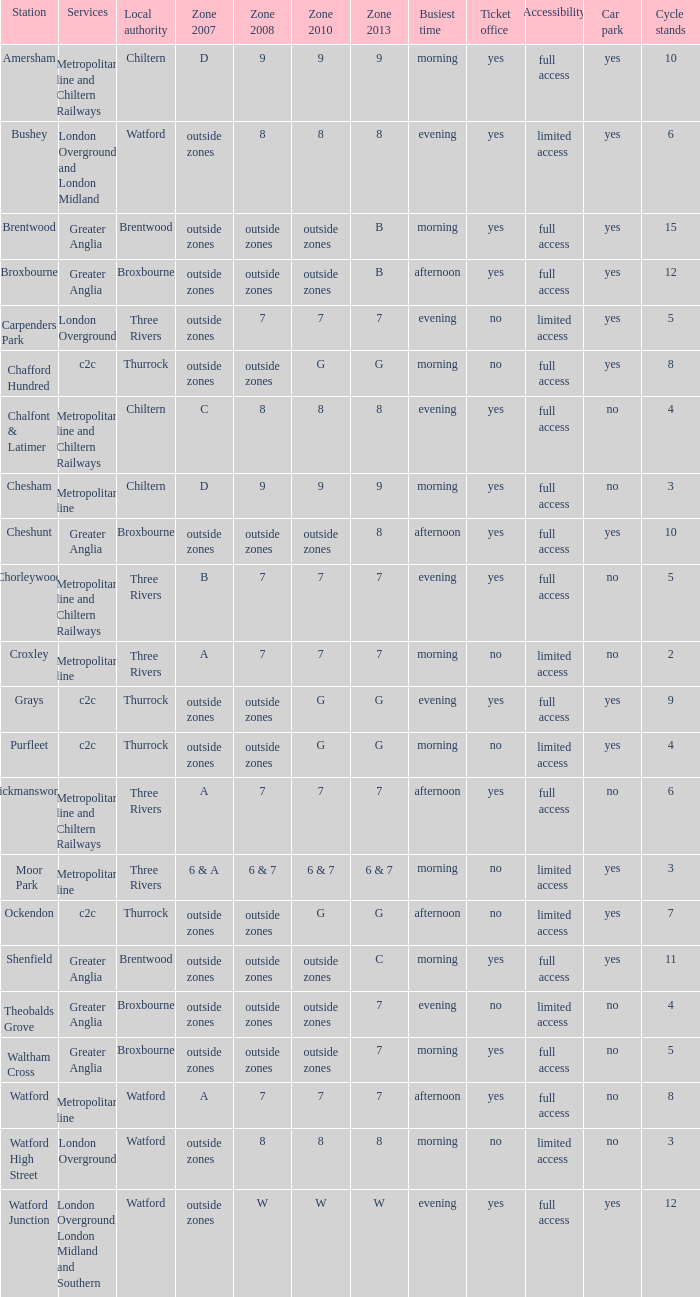Which Services have a Local authority of chiltern, and a Zone 2010 of 9? Metropolitan line and Chiltern Railways, Metropolitan line. 